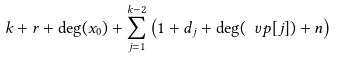Convert formula to latex. <formula><loc_0><loc_0><loc_500><loc_500>k + r + \deg ( x _ { 0 } ) + \sum _ { j = 1 } ^ { k - 2 } \left ( 1 + d _ { j } + \deg ( \ v p [ j ] ) + n \right )</formula> 